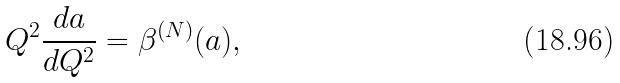<formula> <loc_0><loc_0><loc_500><loc_500>Q ^ { 2 } \frac { d a } { d Q ^ { 2 } } = \beta ^ { ( N ) } ( a ) ,</formula> 